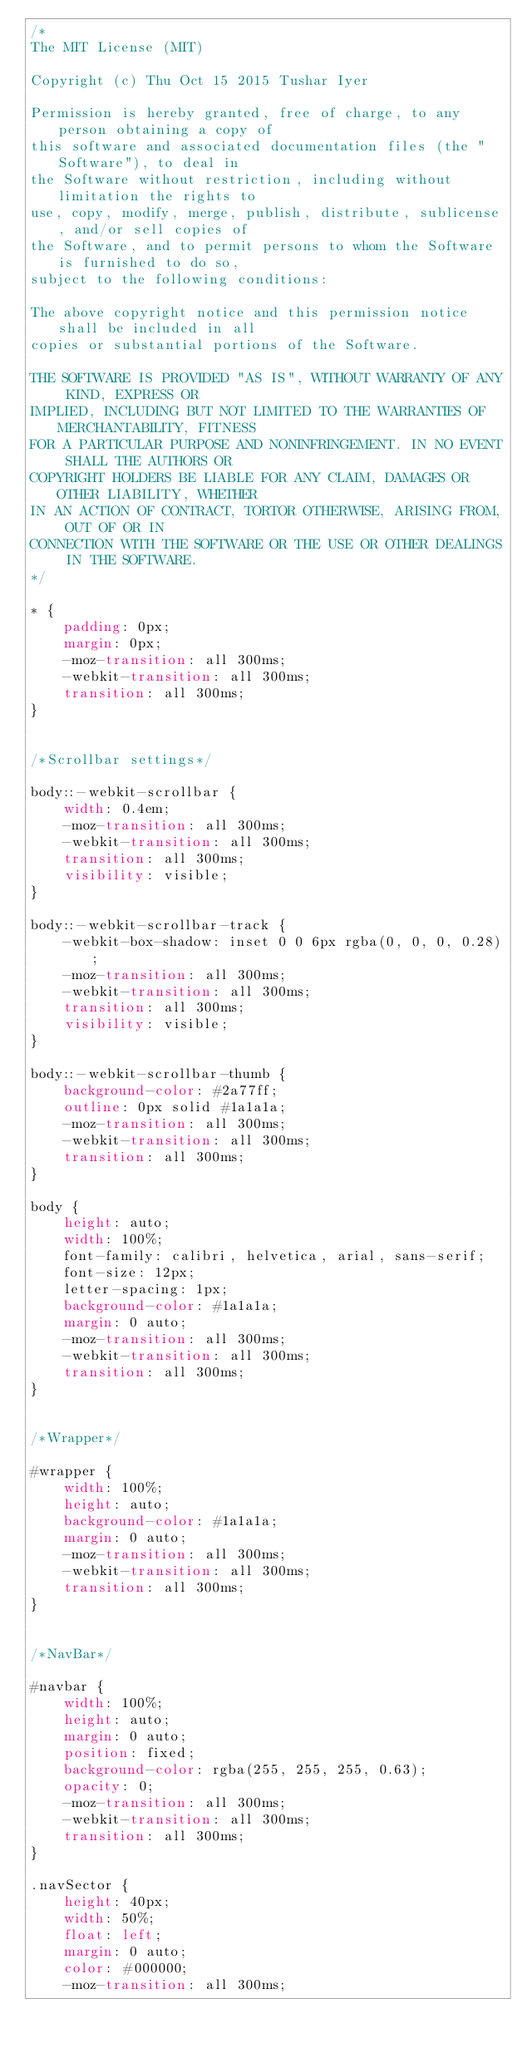Convert code to text. <code><loc_0><loc_0><loc_500><loc_500><_CSS_>/*
The MIT License (MIT)

Copyright (c) Thu Oct 15 2015 Tushar Iyer

Permission is hereby granted, free of charge, to any person obtaining a copy of
this software and associated documentation files (the "Software"), to deal in
the Software without restriction, including without limitation the rights to
use, copy, modify, merge, publish, distribute, sublicense, and/or sell copies of
the Software, and to permit persons to whom the Software is furnished to do so,
subject to the following conditions:

The above copyright notice and this permission notice shall be included in all
copies or substantial portions of the Software.

THE SOFTWARE IS PROVIDED "AS IS", WITHOUT WARRANTY OF ANY KIND, EXPRESS OR
IMPLIED, INCLUDING BUT NOT LIMITED TO THE WARRANTIES OF MERCHANTABILITY, FITNESS
FOR A PARTICULAR PURPOSE AND NONINFRINGEMENT. IN NO EVENT SHALL THE AUTHORS OR
COPYRIGHT HOLDERS BE LIABLE FOR ANY CLAIM, DAMAGES OR OTHER LIABILITY, WHETHER
IN AN ACTION OF CONTRACT, TORTOR OTHERWISE, ARISING FROM, OUT OF OR IN
CONNECTION WITH THE SOFTWARE OR THE USE OR OTHER DEALINGS IN THE SOFTWARE.
*/

* {
    padding: 0px;
    margin: 0px;
    -moz-transition: all 300ms;
    -webkit-transition: all 300ms;
    transition: all 300ms;
}


/*Scrollbar settings*/

body::-webkit-scrollbar {
    width: 0.4em;
    -moz-transition: all 300ms;
    -webkit-transition: all 300ms;
    transition: all 300ms;
    visibility: visible;
}

body::-webkit-scrollbar-track {
    -webkit-box-shadow: inset 0 0 6px rgba(0, 0, 0, 0.28);
    -moz-transition: all 300ms;
    -webkit-transition: all 300ms;
    transition: all 300ms;
    visibility: visible;
}

body::-webkit-scrollbar-thumb {
    background-color: #2a77ff;
    outline: 0px solid #1a1a1a;
    -moz-transition: all 300ms;
    -webkit-transition: all 300ms;
    transition: all 300ms;
}

body {
    height: auto;
    width: 100%;
    font-family: calibri, helvetica, arial, sans-serif;
    font-size: 12px;
    letter-spacing: 1px;
    background-color: #1a1a1a;
    margin: 0 auto;
    -moz-transition: all 300ms;
    -webkit-transition: all 300ms;
    transition: all 300ms;
}


/*Wrapper*/

#wrapper {
    width: 100%;
    height: auto;
    background-color: #1a1a1a;
    margin: 0 auto;
    -moz-transition: all 300ms;
    -webkit-transition: all 300ms;
    transition: all 300ms;
}


/*NavBar*/

#navbar {
    width: 100%;
    height: auto;
    margin: 0 auto;
    position: fixed;
    background-color: rgba(255, 255, 255, 0.63);
    opacity: 0;
    -moz-transition: all 300ms;
    -webkit-transition: all 300ms;
    transition: all 300ms;
}

.navSector {
    height: 40px;
    width: 50%;
    float: left;
    margin: 0 auto;
    color: #000000;
    -moz-transition: all 300ms;</code> 